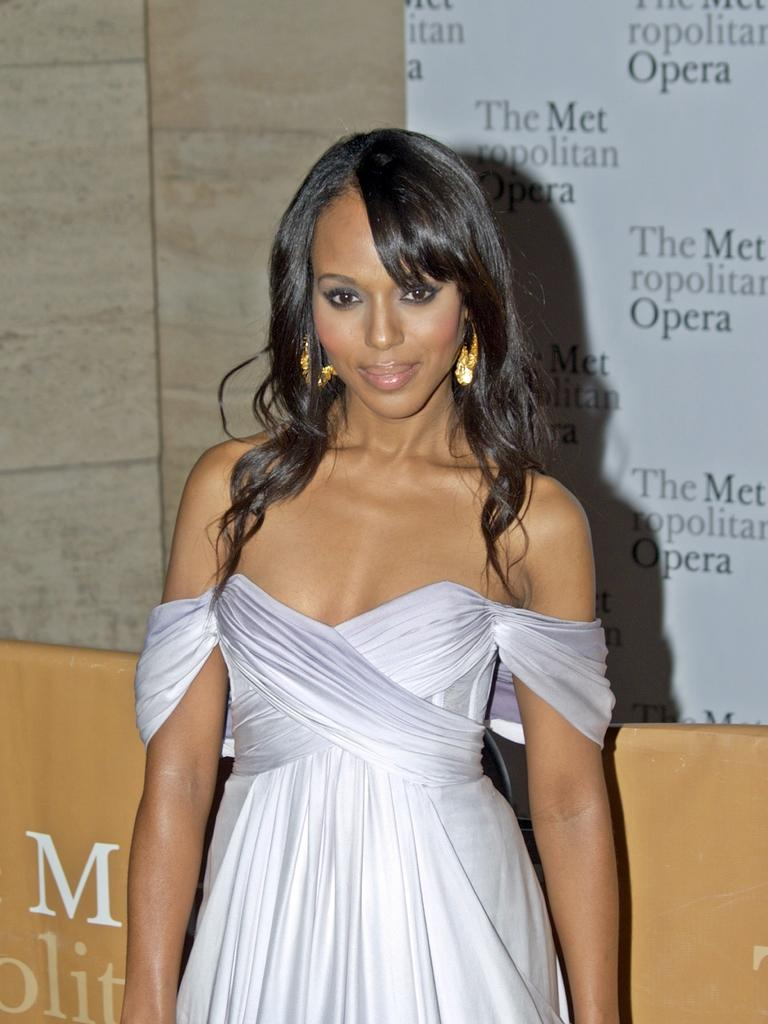Who is present in the image? There is a woman in the image. What is the woman wearing? The woman is wearing a white dress. What is the woman doing in the image? The woman is standing. What can be seen in the background of the image? There is a white banner in the image. What is written on the white banner? There is writing on the white banner. What type of plantation can be seen in the image? There is no plantation present in the image. What does the woman need to do in the image? The image does not provide any information about what the woman needs to do, as it only shows her standing and wearing a white dress. 